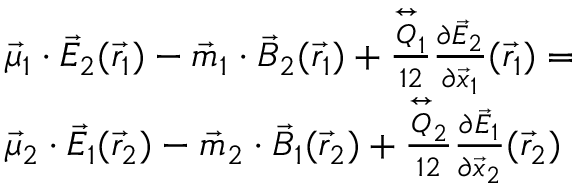<formula> <loc_0><loc_0><loc_500><loc_500>\begin{array} { r l } & { \vec { \mu } _ { 1 } \cdot \vec { E } _ { 2 } ( \vec { r } _ { 1 } ) - \vec { m } _ { 1 } \cdot \vec { B } _ { 2 } ( \vec { r } _ { 1 } ) + \frac { \stackrel { \leftrightarrow } { Q } _ { 1 } } { 1 2 } \frac { \partial \vec { E } _ { 2 } } { \partial \vec { x } _ { 1 } } ( \vec { r } _ { 1 } ) = } \\ & { \vec { \mu } _ { 2 } \cdot \vec { E } _ { 1 } ( \vec { r } _ { 2 } ) - \vec { m } _ { 2 } \cdot \vec { B } _ { 1 } ( \vec { r } _ { 2 } ) + \frac { \stackrel { \leftrightarrow } { Q } _ { 2 } } { 1 2 } \frac { \partial \vec { E } _ { 1 } } { \partial \vec { x } _ { 2 } } ( \vec { r } _ { 2 } ) } \end{array}</formula> 